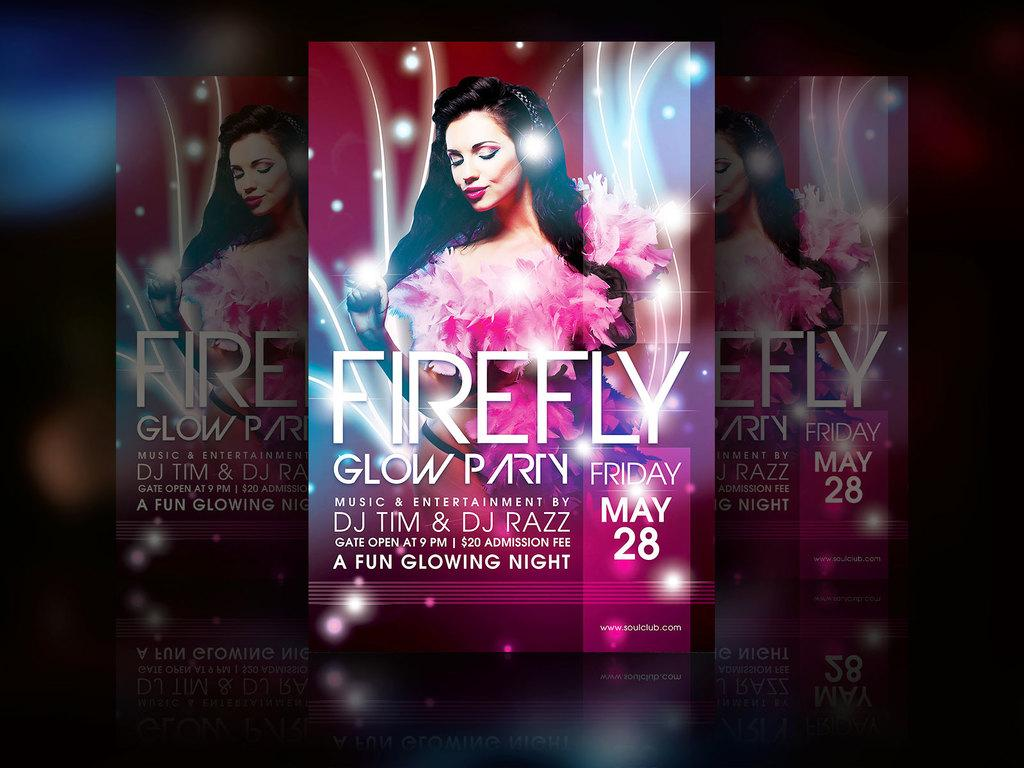<image>
Write a terse but informative summary of the picture. Posters with firefly glow party wrote on the front of it 